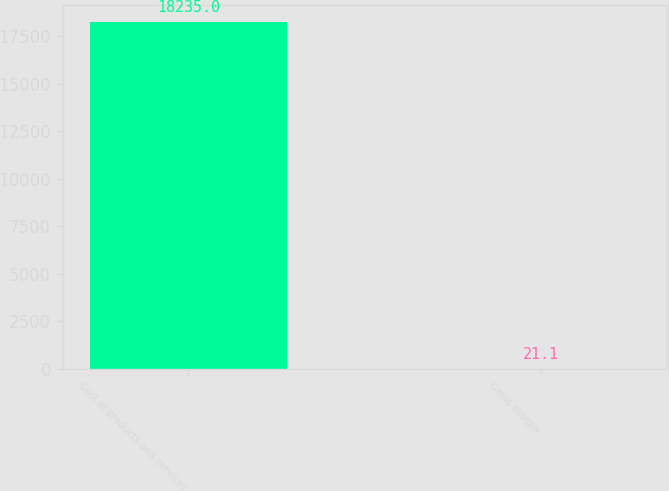<chart> <loc_0><loc_0><loc_500><loc_500><bar_chart><fcel>Cost of products and services<fcel>Gross margin<nl><fcel>18235<fcel>21.1<nl></chart> 